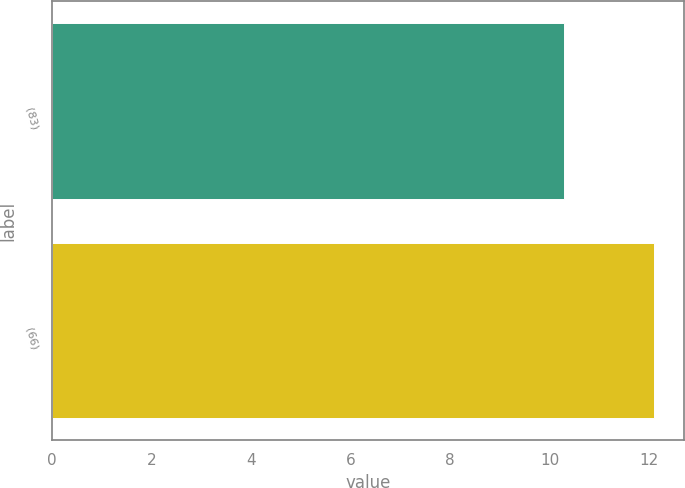Convert chart. <chart><loc_0><loc_0><loc_500><loc_500><bar_chart><fcel>(83)<fcel>(66)<nl><fcel>10.3<fcel>12.1<nl></chart> 